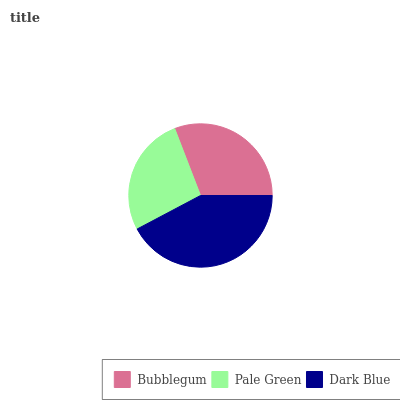Is Pale Green the minimum?
Answer yes or no. Yes. Is Dark Blue the maximum?
Answer yes or no. Yes. Is Dark Blue the minimum?
Answer yes or no. No. Is Pale Green the maximum?
Answer yes or no. No. Is Dark Blue greater than Pale Green?
Answer yes or no. Yes. Is Pale Green less than Dark Blue?
Answer yes or no. Yes. Is Pale Green greater than Dark Blue?
Answer yes or no. No. Is Dark Blue less than Pale Green?
Answer yes or no. No. Is Bubblegum the high median?
Answer yes or no. Yes. Is Bubblegum the low median?
Answer yes or no. Yes. Is Pale Green the high median?
Answer yes or no. No. Is Dark Blue the low median?
Answer yes or no. No. 